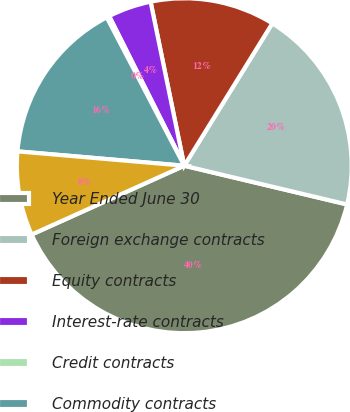Convert chart to OTSL. <chart><loc_0><loc_0><loc_500><loc_500><pie_chart><fcel>Year Ended June 30<fcel>Foreign exchange contracts<fcel>Equity contracts<fcel>Interest-rate contracts<fcel>Credit contracts<fcel>Commodity contracts<fcel>Total<nl><fcel>39.54%<fcel>19.9%<fcel>12.04%<fcel>4.18%<fcel>0.26%<fcel>15.97%<fcel>8.11%<nl></chart> 